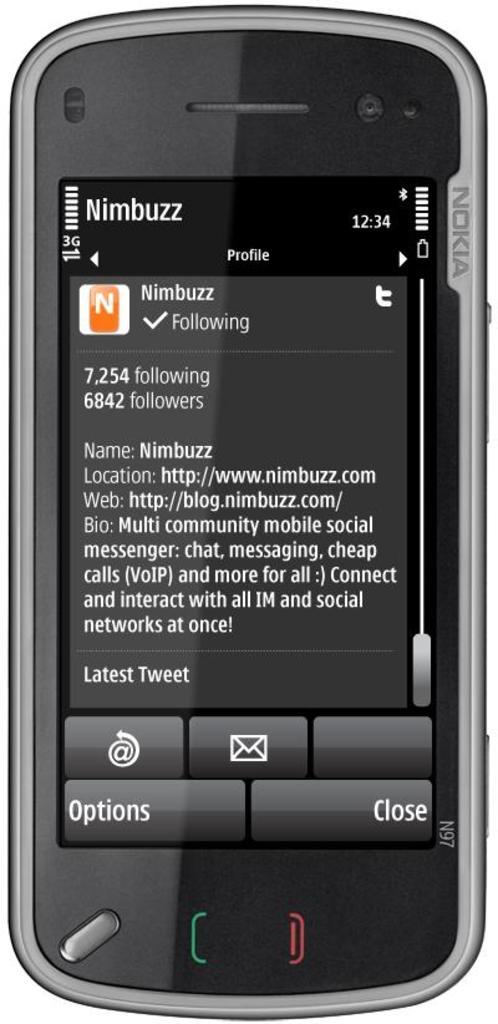<image>
Describe the image concisely. an Nimbuzz app on a Nokia phone. 